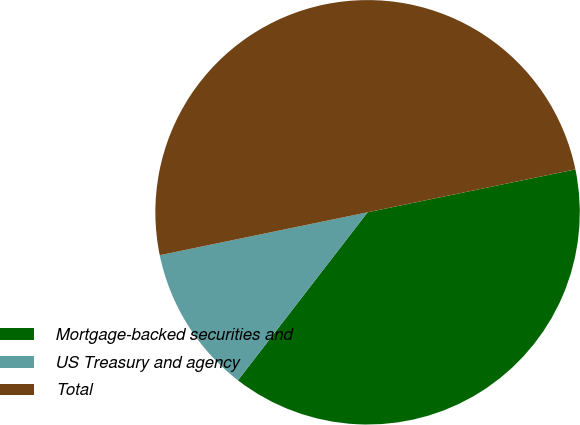Convert chart. <chart><loc_0><loc_0><loc_500><loc_500><pie_chart><fcel>Mortgage-backed securities and<fcel>US Treasury and agency<fcel>Total<nl><fcel>38.7%<fcel>11.3%<fcel>50.0%<nl></chart> 